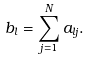Convert formula to latex. <formula><loc_0><loc_0><loc_500><loc_500>b _ { l } = \sum ^ { N } _ { j = 1 } a _ { l j } .</formula> 